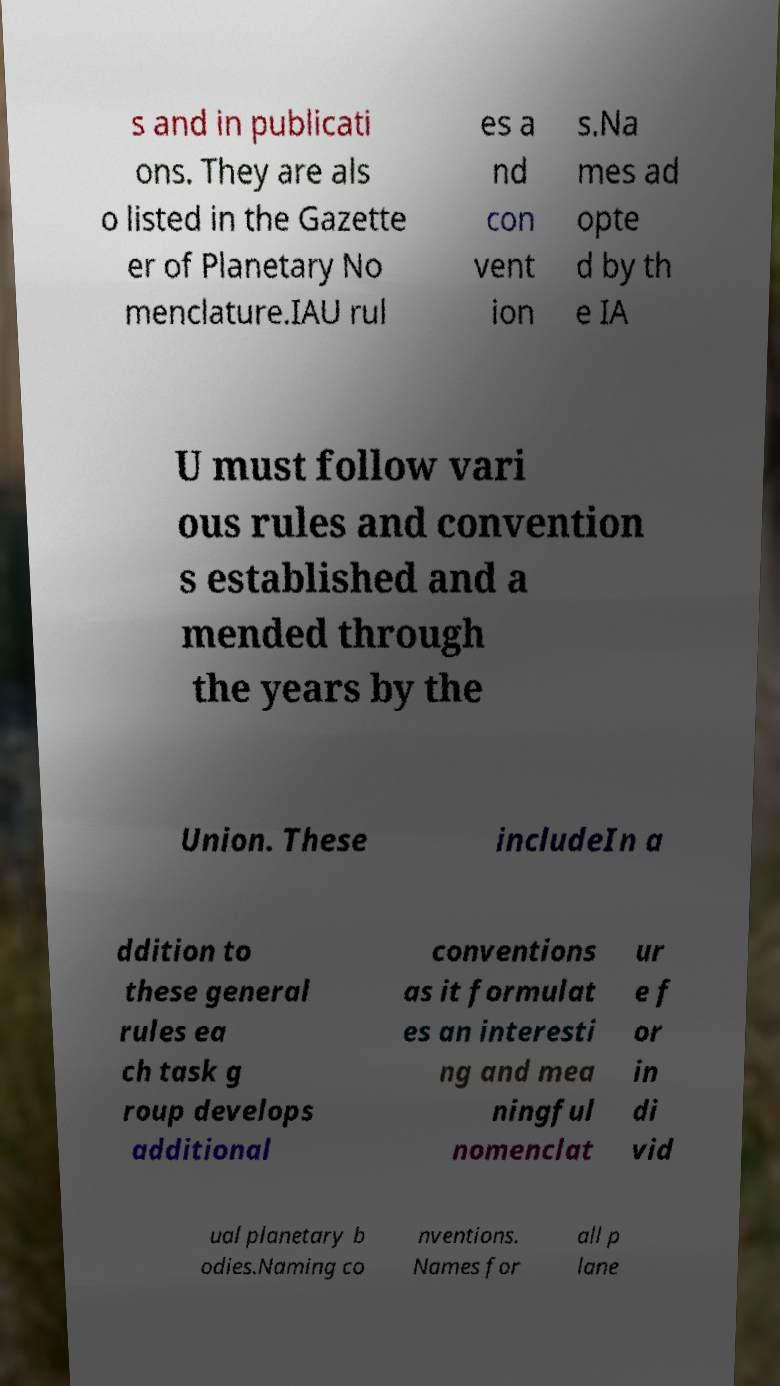What messages or text are displayed in this image? I need them in a readable, typed format. s and in publicati ons. They are als o listed in the Gazette er of Planetary No menclature.IAU rul es a nd con vent ion s.Na mes ad opte d by th e IA U must follow vari ous rules and convention s established and a mended through the years by the Union. These includeIn a ddition to these general rules ea ch task g roup develops additional conventions as it formulat es an interesti ng and mea ningful nomenclat ur e f or in di vid ual planetary b odies.Naming co nventions. Names for all p lane 